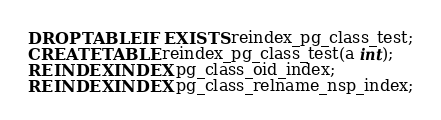<code> <loc_0><loc_0><loc_500><loc_500><_SQL_>DROP TABLE IF EXISTS reindex_pg_class_test;
CREATE TABLE reindex_pg_class_test(a int);
REINDEX INDEX pg_class_oid_index;
REINDEX INDEX pg_class_relname_nsp_index;
</code> 